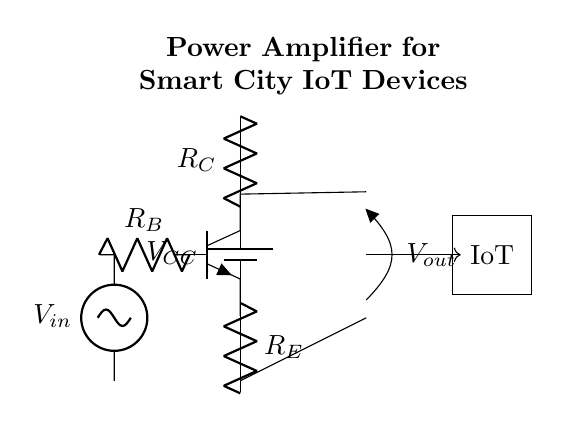What is the type of transistor used in this circuit? The circuit diagram shows an NPN transistor, which is indicated by the npn label in the circuit.
Answer: NPN What are the values of the resistors labeled in the circuit? The circuit diagram includes three resistors: base resistor (R_B), emitter resistor (R_E), and collector resistor (R_C). However, their specific values are not provided in the diagram.
Answer: R_B, R_E, R_C Where is the input signal applied in the circuit? The input signal, labeled V_in, is connected to the base of the NPN transistor through the base resistor, R_B. This connection allows the transistor to amplify the input signal.
Answer: Base of the NPN transistor What function do the resistors R_E and R_C serve in this circuit? R_E is used for stabilizing the operating point of the transistor, while R_C is used to develop the output voltage, thus allowing for amplification. Both resistors are crucial for the correct operation of the amplifier circuit.
Answer: Stabilizing and output voltage development What is the purpose of the output labeled V_out in the circuit? V_out represents the amplified signal output from the collector of the NPN transistor, which can be supplied to an IoT device for further processing or use in smart city applications.
Answer: Amplified signal output How does this amplifier circuit relate to IoT devices in a smart city? This amplifier circuit is designed to take a small signal input and amplify it for use by IoT devices, which require reliable signal levels for operation, essential in smart city infrastructure for efficient data transmission.
Answer: Amplifies signals for IoT What is the role of the battery in this amplifier circuit? The battery labeled V_CC provides the necessary power supply for the circuit, enabling the NPN transistor to operate and perform signal amplification. Without this power source, the circuit would not function.
Answer: Power supply 